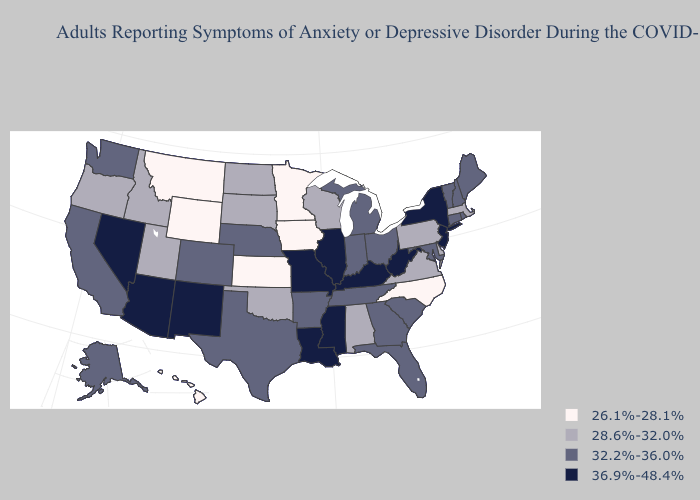What is the lowest value in the USA?
Be succinct. 26.1%-28.1%. Name the states that have a value in the range 32.2%-36.0%?
Be succinct. Alaska, Arkansas, California, Colorado, Connecticut, Florida, Georgia, Indiana, Maine, Maryland, Michigan, Nebraska, New Hampshire, Ohio, Rhode Island, South Carolina, Tennessee, Texas, Vermont, Washington. Does Nebraska have the highest value in the USA?
Answer briefly. No. Which states have the lowest value in the West?
Concise answer only. Hawaii, Montana, Wyoming. Which states have the lowest value in the USA?
Give a very brief answer. Hawaii, Iowa, Kansas, Minnesota, Montana, North Carolina, Wyoming. Does New Jersey have the highest value in the Northeast?
Be succinct. Yes. What is the lowest value in the USA?
Quick response, please. 26.1%-28.1%. Among the states that border Maryland , does Delaware have the highest value?
Answer briefly. No. What is the value of Missouri?
Concise answer only. 36.9%-48.4%. What is the highest value in the West ?
Concise answer only. 36.9%-48.4%. Name the states that have a value in the range 26.1%-28.1%?
Concise answer only. Hawaii, Iowa, Kansas, Minnesota, Montana, North Carolina, Wyoming. What is the value of Connecticut?
Concise answer only. 32.2%-36.0%. Does the first symbol in the legend represent the smallest category?
Give a very brief answer. Yes. Name the states that have a value in the range 32.2%-36.0%?
Short answer required. Alaska, Arkansas, California, Colorado, Connecticut, Florida, Georgia, Indiana, Maine, Maryland, Michigan, Nebraska, New Hampshire, Ohio, Rhode Island, South Carolina, Tennessee, Texas, Vermont, Washington. Which states have the highest value in the USA?
Concise answer only. Arizona, Illinois, Kentucky, Louisiana, Mississippi, Missouri, Nevada, New Jersey, New Mexico, New York, West Virginia. 